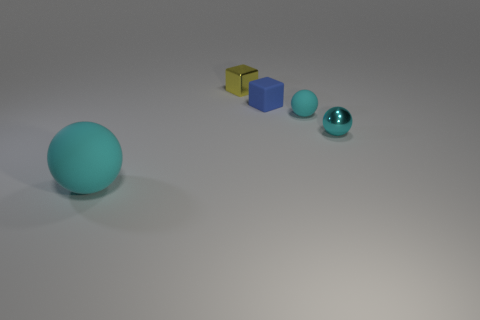Add 1 small yellow objects. How many small yellow objects exist? 2 Add 4 big brown cylinders. How many objects exist? 9 Subtract all blue blocks. How many blocks are left? 1 Subtract all tiny balls. How many balls are left? 1 Subtract 0 red balls. How many objects are left? 5 Subtract all blocks. How many objects are left? 3 Subtract 2 spheres. How many spheres are left? 1 Subtract all yellow cubes. Subtract all blue cylinders. How many cubes are left? 1 Subtract all purple spheres. How many green cubes are left? 0 Subtract all cyan matte spheres. Subtract all big yellow rubber spheres. How many objects are left? 3 